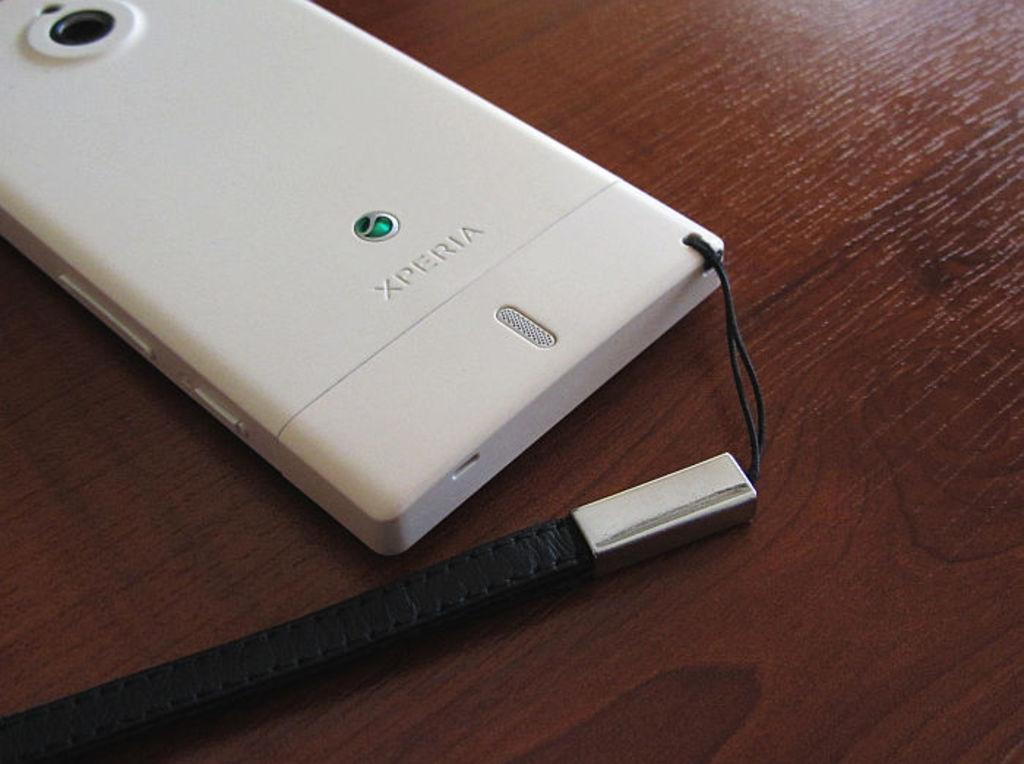<image>
Present a compact description of the photo's key features. A cell phone with XPERIA written on the back of it. 